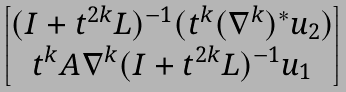Convert formula to latex. <formula><loc_0><loc_0><loc_500><loc_500>\begin{bmatrix} ( I + t ^ { 2 k } L ) ^ { - 1 } ( t ^ { k } ( \nabla ^ { k } ) ^ { * } u _ { 2 } ) \\ t ^ { k } A \nabla ^ { k } ( I + t ^ { 2 k } L ) ^ { - 1 } u _ { 1 } \end{bmatrix}</formula> 